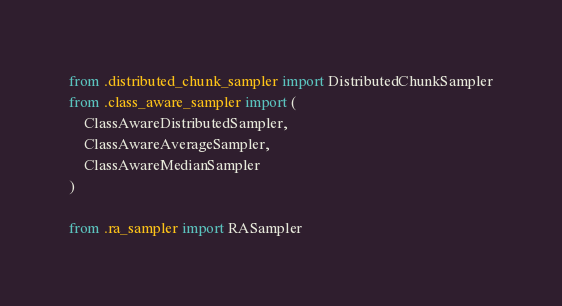Convert code to text. <code><loc_0><loc_0><loc_500><loc_500><_Python_>from .distributed_chunk_sampler import DistributedChunkSampler
from .class_aware_sampler import (
    ClassAwareDistributedSampler,
    ClassAwareAverageSampler,
    ClassAwareMedianSampler
)

from .ra_sampler import RASampler
</code> 